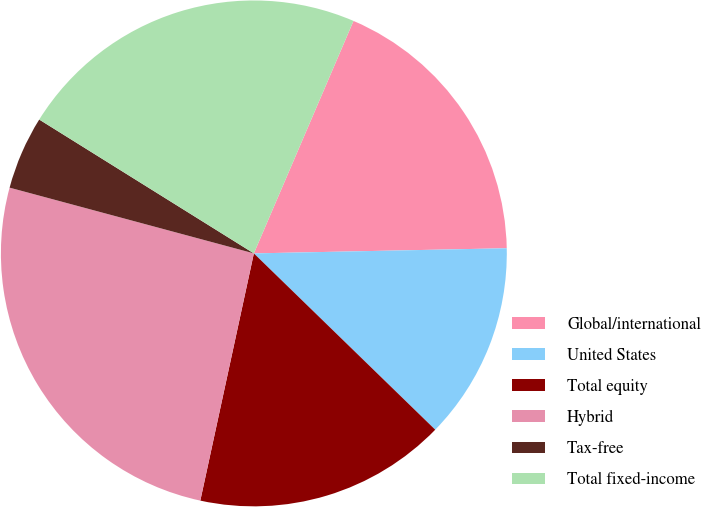<chart> <loc_0><loc_0><loc_500><loc_500><pie_chart><fcel>Global/international<fcel>United States<fcel>Total equity<fcel>Hybrid<fcel>Tax-free<fcel>Total fixed-income<nl><fcel>18.23%<fcel>12.6%<fcel>16.12%<fcel>25.79%<fcel>4.69%<fcel>22.57%<nl></chart> 